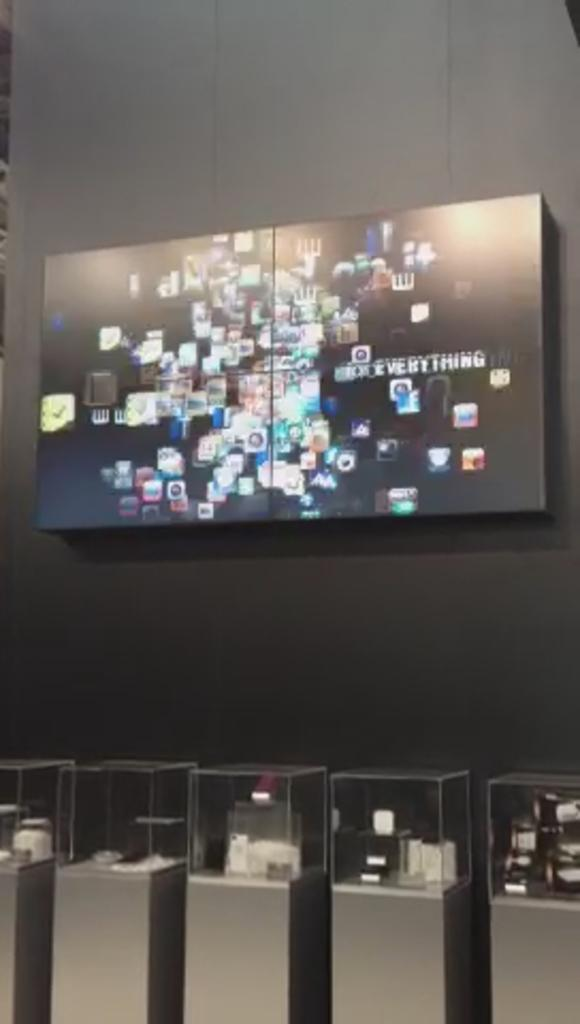<image>
Summarize the visual content of the image. Big tv screen with the writing everything on it 